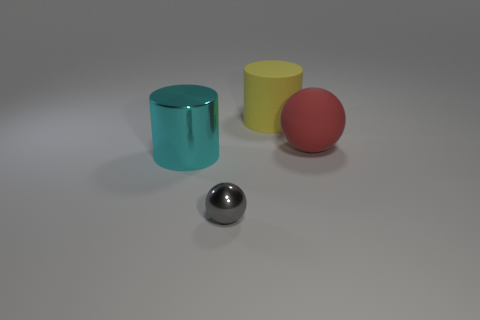How do you think the light is affecting the ambience of this image? The lighting in this image seems to come from above, casting soft, diffuse shadows that contribute to a calm and serene atmosphere. There's no harsh light, which gives the scene a gentle and even ambience, accentuating the textures and colors of the objects without creating strong contrasts or dramatic tension. 